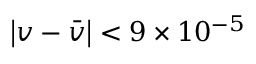<formula> <loc_0><loc_0><loc_500><loc_500>\left | v - { \bar { v } } \right | < 9 \times 1 0 ^ { - 5 }</formula> 